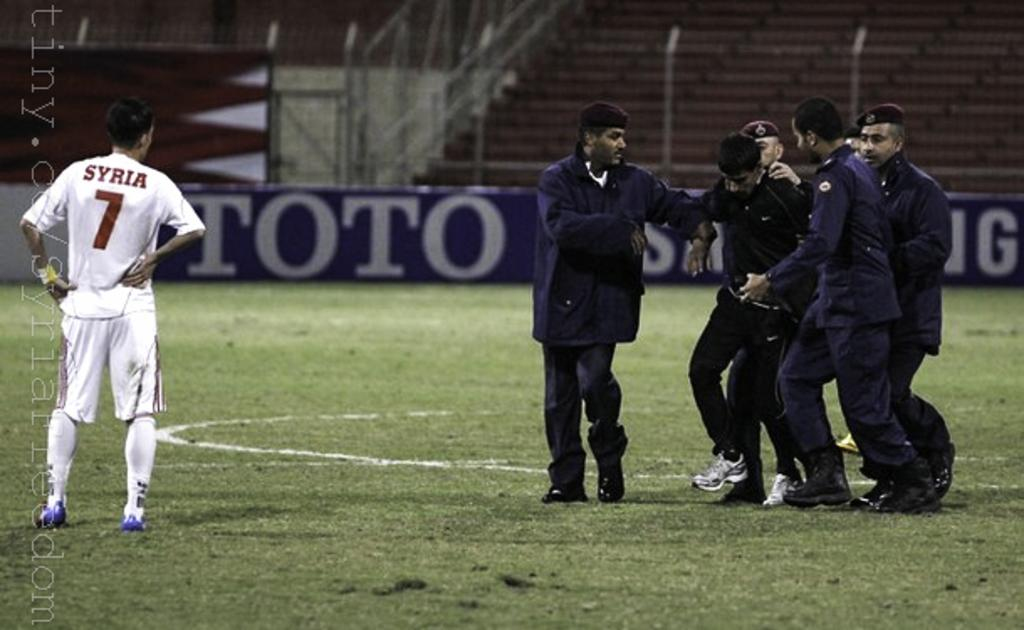<image>
Give a short and clear explanation of the subsequent image. Several men are helping a player off the field while another player, wearing number 7, watches. 